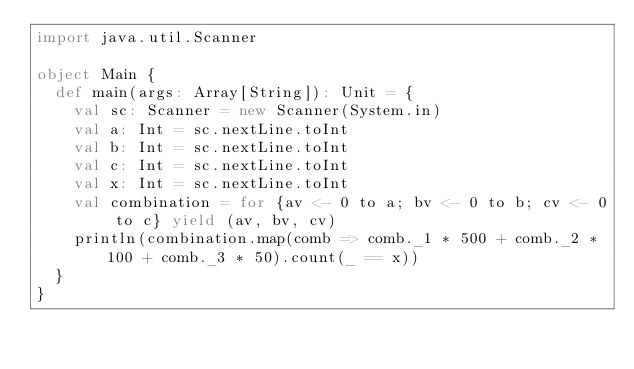<code> <loc_0><loc_0><loc_500><loc_500><_Scala_>import java.util.Scanner

object Main {
  def main(args: Array[String]): Unit = {
    val sc: Scanner = new Scanner(System.in)
    val a: Int = sc.nextLine.toInt
    val b: Int = sc.nextLine.toInt
    val c: Int = sc.nextLine.toInt
    val x: Int = sc.nextLine.toInt
    val combination = for {av <- 0 to a; bv <- 0 to b; cv <- 0 to c} yield (av, bv, cv)
    println(combination.map(comb => comb._1 * 500 + comb._2 * 100 + comb._3 * 50).count(_ == x))
  }
}
</code> 